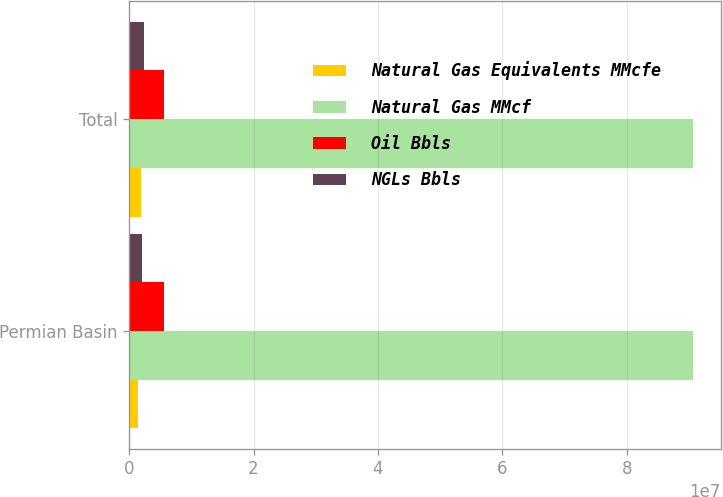Convert chart to OTSL. <chart><loc_0><loc_0><loc_500><loc_500><stacked_bar_chart><ecel><fcel>Permian Basin<fcel>Total<nl><fcel>Natural Gas Equivalents MMcfe<fcel>1.51033e+06<fcel>1.89616e+06<nl><fcel>Natural Gas MMcf<fcel>9.05856e+07<fcel>9.05856e+07<nl><fcel>Oil Bbls<fcel>5.642e+06<fcel>5.6963e+06<nl><fcel>NGLs Bbls<fcel>2.0877e+06<fcel>2.47385e+06<nl></chart> 